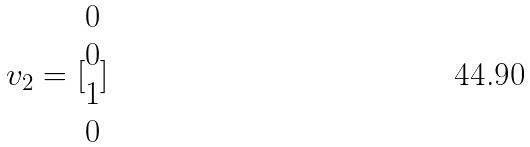Convert formula to latex. <formula><loc_0><loc_0><loc_500><loc_500>v _ { 2 } = [ \begin{matrix} 0 \\ 0 \\ 1 \\ 0 \end{matrix} ]</formula> 